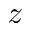Convert formula to latex. <formula><loc_0><loc_0><loc_500><loc_500>z</formula> 